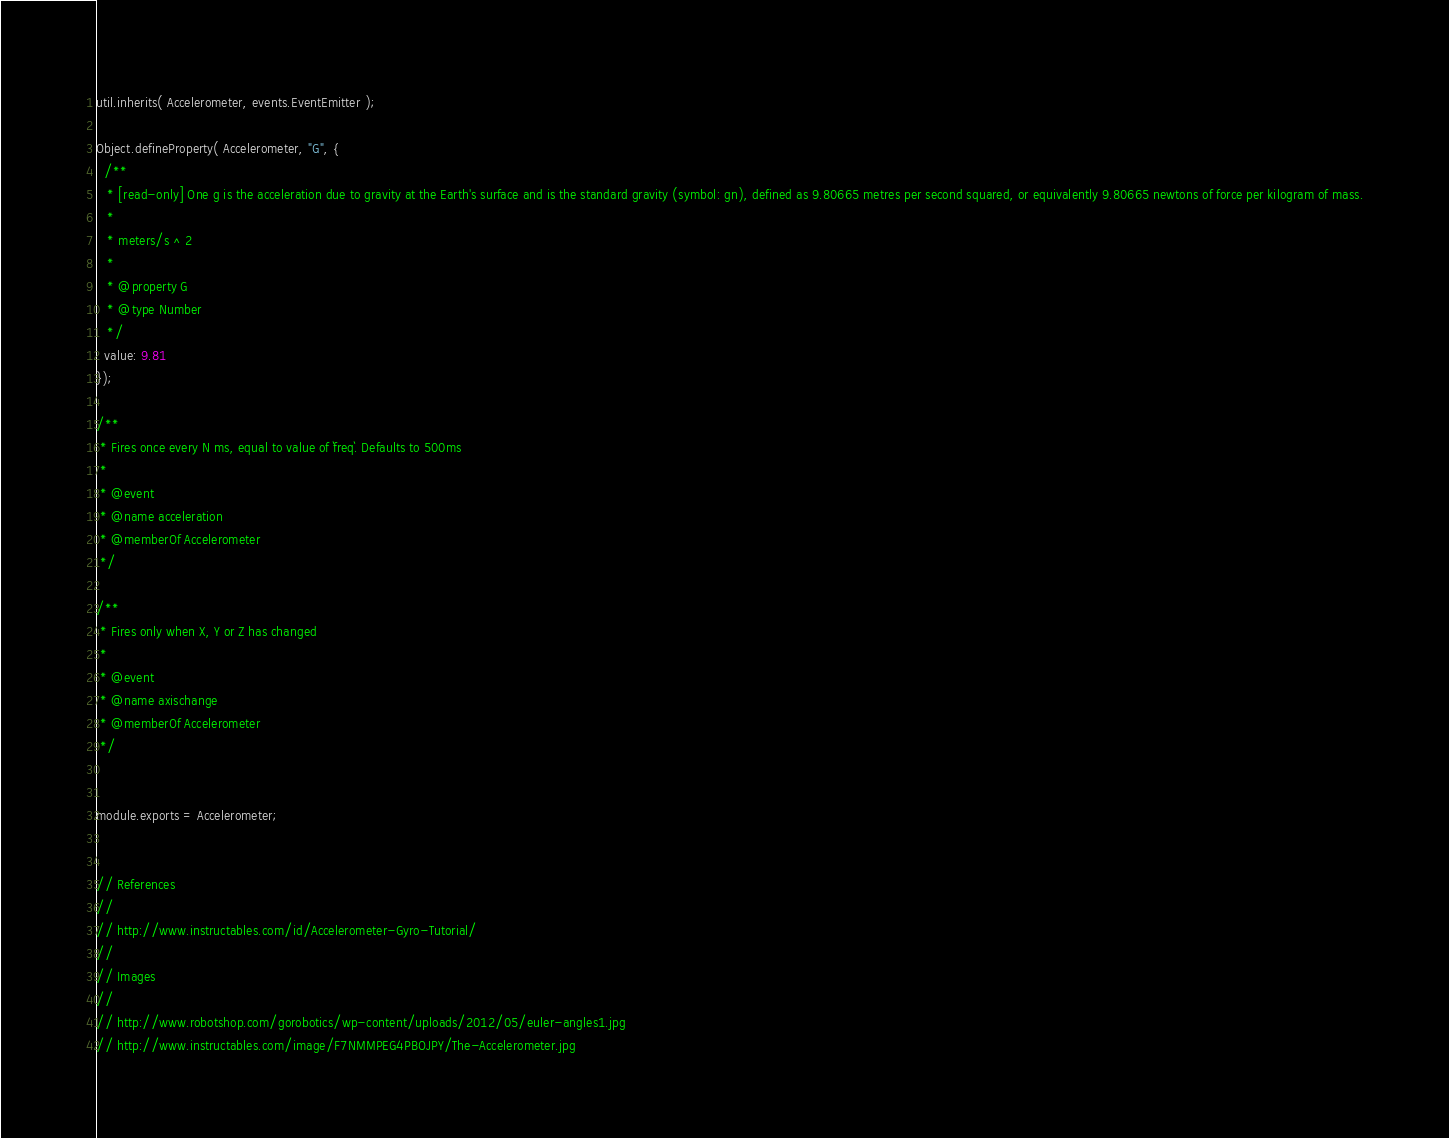Convert code to text. <code><loc_0><loc_0><loc_500><loc_500><_JavaScript_>
util.inherits( Accelerometer, events.EventEmitter );

Object.defineProperty( Accelerometer, "G", {
  /**
   * [read-only] One g is the acceleration due to gravity at the Earth's surface and is the standard gravity (symbol: gn), defined as 9.80665 metres per second squared, or equivalently 9.80665 newtons of force per kilogram of mass.
   *
   * meters/s ^ 2
   *
   * @property G
   * @type Number
   */
  value: 9.81
});

/**
 * Fires once every N ms, equal to value of `freq`. Defaults to 500ms
 *
 * @event
 * @name acceleration
 * @memberOf Accelerometer
 */

/**
 * Fires only when X, Y or Z has changed
 *
 * @event
 * @name axischange
 * @memberOf Accelerometer
 */


module.exports = Accelerometer;


// References
//
// http://www.instructables.com/id/Accelerometer-Gyro-Tutorial/
//
// Images
//
// http://www.robotshop.com/gorobotics/wp-content/uploads/2012/05/euler-angles1.jpg
// http://www.instructables.com/image/F7NMMPEG4PBOJPY/The-Accelerometer.jpg
</code> 